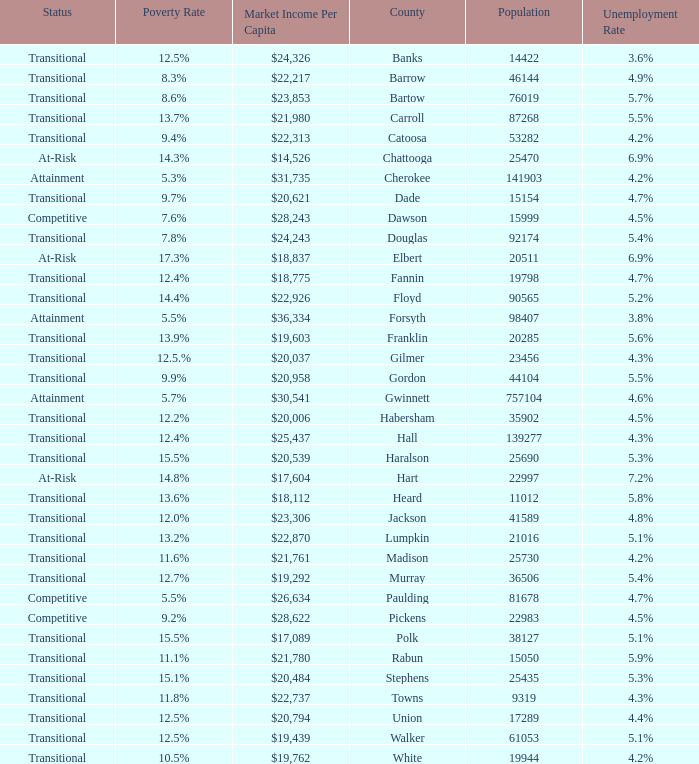What is the market income per capita of the county with the 9.4% poverty rate? $22,313. 